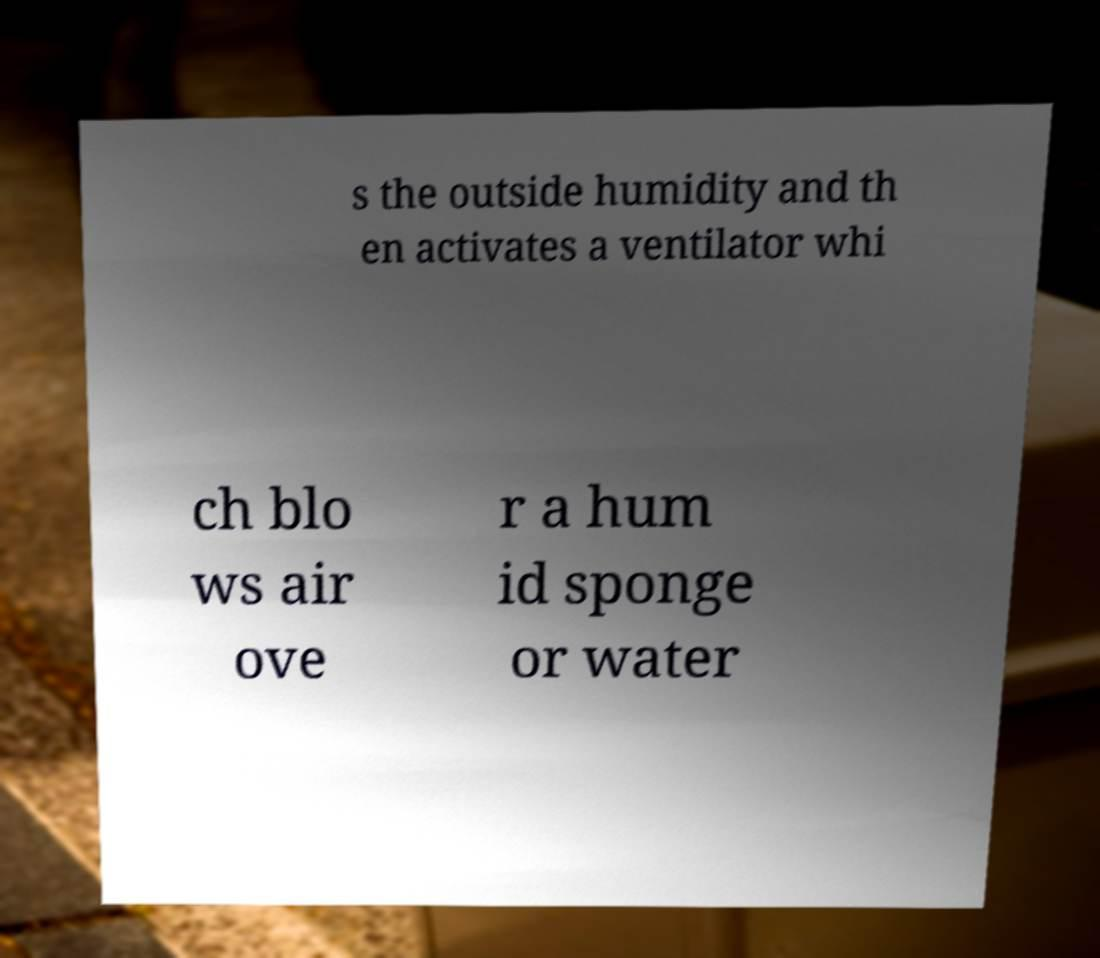For documentation purposes, I need the text within this image transcribed. Could you provide that? s the outside humidity and th en activates a ventilator whi ch blo ws air ove r a hum id sponge or water 